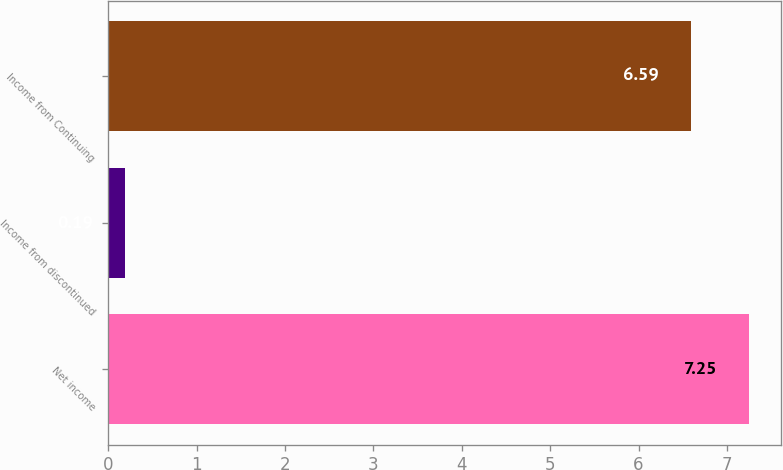Convert chart. <chart><loc_0><loc_0><loc_500><loc_500><bar_chart><fcel>Net income<fcel>Income from discontinued<fcel>Income from Continuing<nl><fcel>7.25<fcel>0.19<fcel>6.59<nl></chart> 